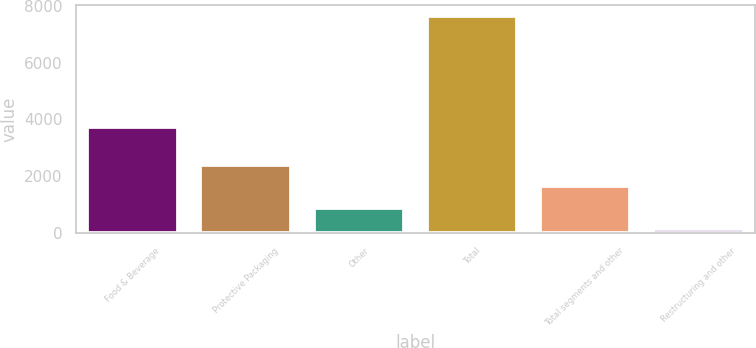Convert chart. <chart><loc_0><loc_0><loc_500><loc_500><bar_chart><fcel>Food & Beverage<fcel>Protective Packaging<fcel>Other<fcel>Total<fcel>Total segments and other<fcel>Restructuring and other<nl><fcel>3739.6<fcel>2394.18<fcel>893.06<fcel>7648.1<fcel>1643.62<fcel>142.5<nl></chart> 